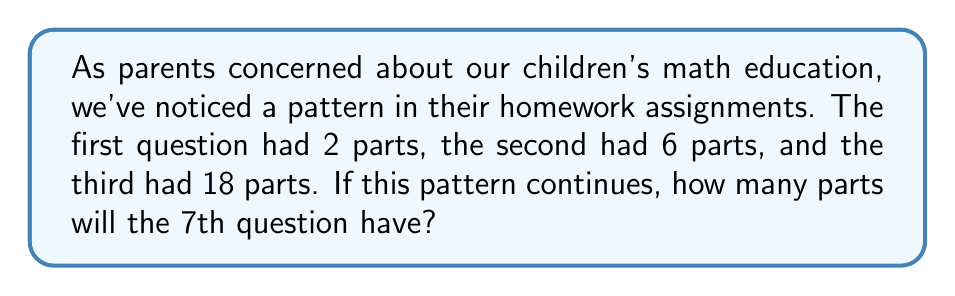Provide a solution to this math problem. Let's approach this step-by-step:

1) First, we need to identify that this is a geometric sequence. We can see this by looking at the ratio between consecutive terms:

   $\frac{6}{2} = 3$ and $\frac{18}{6} = 3$

2) The general form of a geometric sequence is:

   $a_n = a_1 \cdot r^{n-1}$

   Where $a_n$ is the nth term, $a_1$ is the first term, and $r$ is the common ratio.

3) In this case:
   $a_1 = 2$ (the first term)
   $r = 3$ (the common ratio)

4) We want to find the 7th term, so $n = 7$

5) Let's substitute these values into our formula:

   $a_7 = 2 \cdot 3^{7-1}$

6) Simplify:
   $a_7 = 2 \cdot 3^6$

7) Calculate:
   $a_7 = 2 \cdot 729 = 1458$

Therefore, the 7th question will have 1458 parts.
Answer: 1458 